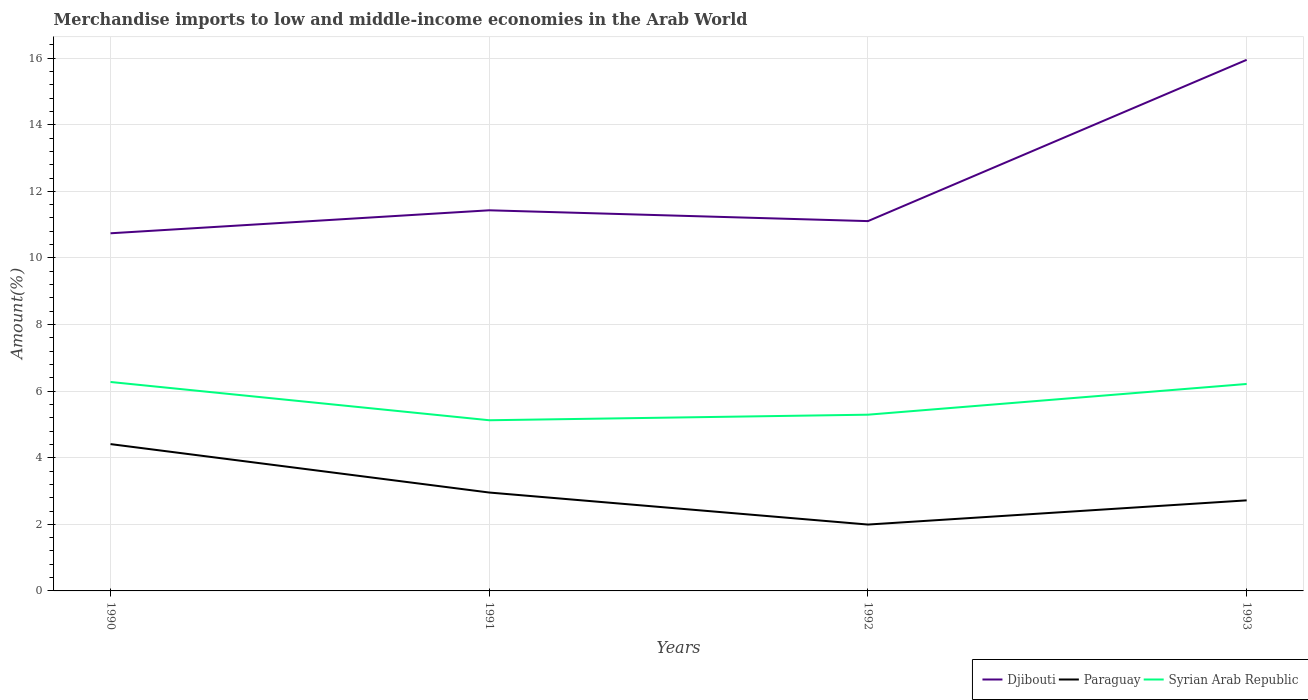Does the line corresponding to Syrian Arab Republic intersect with the line corresponding to Djibouti?
Ensure brevity in your answer.  No. Across all years, what is the maximum percentage of amount earned from merchandise imports in Djibouti?
Your answer should be compact. 10.74. What is the total percentage of amount earned from merchandise imports in Syrian Arab Republic in the graph?
Your answer should be very brief. 0.06. What is the difference between the highest and the second highest percentage of amount earned from merchandise imports in Paraguay?
Offer a terse response. 2.42. What is the difference between the highest and the lowest percentage of amount earned from merchandise imports in Djibouti?
Ensure brevity in your answer.  1. Is the percentage of amount earned from merchandise imports in Paraguay strictly greater than the percentage of amount earned from merchandise imports in Djibouti over the years?
Your answer should be very brief. Yes. How many lines are there?
Provide a short and direct response. 3. How many years are there in the graph?
Make the answer very short. 4. Where does the legend appear in the graph?
Your answer should be very brief. Bottom right. How many legend labels are there?
Offer a terse response. 3. How are the legend labels stacked?
Your response must be concise. Horizontal. What is the title of the graph?
Keep it short and to the point. Merchandise imports to low and middle-income economies in the Arab World. What is the label or title of the Y-axis?
Your response must be concise. Amount(%). What is the Amount(%) of Djibouti in 1990?
Your answer should be compact. 10.74. What is the Amount(%) in Paraguay in 1990?
Your response must be concise. 4.41. What is the Amount(%) of Syrian Arab Republic in 1990?
Your response must be concise. 6.27. What is the Amount(%) of Djibouti in 1991?
Your answer should be compact. 11.43. What is the Amount(%) in Paraguay in 1991?
Your answer should be very brief. 2.95. What is the Amount(%) in Syrian Arab Republic in 1991?
Offer a terse response. 5.13. What is the Amount(%) in Djibouti in 1992?
Your answer should be very brief. 11.11. What is the Amount(%) of Paraguay in 1992?
Offer a terse response. 1.99. What is the Amount(%) in Syrian Arab Republic in 1992?
Make the answer very short. 5.29. What is the Amount(%) of Djibouti in 1993?
Your answer should be very brief. 15.95. What is the Amount(%) of Paraguay in 1993?
Your response must be concise. 2.72. What is the Amount(%) in Syrian Arab Republic in 1993?
Make the answer very short. 6.22. Across all years, what is the maximum Amount(%) of Djibouti?
Provide a succinct answer. 15.95. Across all years, what is the maximum Amount(%) of Paraguay?
Make the answer very short. 4.41. Across all years, what is the maximum Amount(%) of Syrian Arab Republic?
Your answer should be very brief. 6.27. Across all years, what is the minimum Amount(%) of Djibouti?
Keep it short and to the point. 10.74. Across all years, what is the minimum Amount(%) in Paraguay?
Ensure brevity in your answer.  1.99. Across all years, what is the minimum Amount(%) in Syrian Arab Republic?
Provide a short and direct response. 5.13. What is the total Amount(%) in Djibouti in the graph?
Give a very brief answer. 49.23. What is the total Amount(%) of Paraguay in the graph?
Your answer should be very brief. 12.08. What is the total Amount(%) of Syrian Arab Republic in the graph?
Give a very brief answer. 22.91. What is the difference between the Amount(%) in Djibouti in 1990 and that in 1991?
Make the answer very short. -0.69. What is the difference between the Amount(%) in Paraguay in 1990 and that in 1991?
Keep it short and to the point. 1.45. What is the difference between the Amount(%) of Syrian Arab Republic in 1990 and that in 1991?
Provide a succinct answer. 1.15. What is the difference between the Amount(%) of Djibouti in 1990 and that in 1992?
Offer a very short reply. -0.37. What is the difference between the Amount(%) in Paraguay in 1990 and that in 1992?
Provide a short and direct response. 2.42. What is the difference between the Amount(%) in Syrian Arab Republic in 1990 and that in 1992?
Ensure brevity in your answer.  0.98. What is the difference between the Amount(%) in Djibouti in 1990 and that in 1993?
Ensure brevity in your answer.  -5.21. What is the difference between the Amount(%) of Paraguay in 1990 and that in 1993?
Make the answer very short. 1.69. What is the difference between the Amount(%) of Syrian Arab Republic in 1990 and that in 1993?
Keep it short and to the point. 0.06. What is the difference between the Amount(%) of Djibouti in 1991 and that in 1992?
Make the answer very short. 0.32. What is the difference between the Amount(%) of Paraguay in 1991 and that in 1992?
Offer a terse response. 0.96. What is the difference between the Amount(%) in Syrian Arab Republic in 1991 and that in 1992?
Ensure brevity in your answer.  -0.17. What is the difference between the Amount(%) of Djibouti in 1991 and that in 1993?
Offer a terse response. -4.52. What is the difference between the Amount(%) of Paraguay in 1991 and that in 1993?
Keep it short and to the point. 0.23. What is the difference between the Amount(%) in Syrian Arab Republic in 1991 and that in 1993?
Your answer should be very brief. -1.09. What is the difference between the Amount(%) in Djibouti in 1992 and that in 1993?
Ensure brevity in your answer.  -4.84. What is the difference between the Amount(%) of Paraguay in 1992 and that in 1993?
Make the answer very short. -0.73. What is the difference between the Amount(%) in Syrian Arab Republic in 1992 and that in 1993?
Make the answer very short. -0.92. What is the difference between the Amount(%) of Djibouti in 1990 and the Amount(%) of Paraguay in 1991?
Give a very brief answer. 7.79. What is the difference between the Amount(%) in Djibouti in 1990 and the Amount(%) in Syrian Arab Republic in 1991?
Your answer should be very brief. 5.61. What is the difference between the Amount(%) of Paraguay in 1990 and the Amount(%) of Syrian Arab Republic in 1991?
Your response must be concise. -0.72. What is the difference between the Amount(%) of Djibouti in 1990 and the Amount(%) of Paraguay in 1992?
Your answer should be compact. 8.75. What is the difference between the Amount(%) in Djibouti in 1990 and the Amount(%) in Syrian Arab Republic in 1992?
Provide a short and direct response. 5.45. What is the difference between the Amount(%) in Paraguay in 1990 and the Amount(%) in Syrian Arab Republic in 1992?
Provide a succinct answer. -0.88. What is the difference between the Amount(%) in Djibouti in 1990 and the Amount(%) in Paraguay in 1993?
Provide a short and direct response. 8.02. What is the difference between the Amount(%) in Djibouti in 1990 and the Amount(%) in Syrian Arab Republic in 1993?
Ensure brevity in your answer.  4.53. What is the difference between the Amount(%) of Paraguay in 1990 and the Amount(%) of Syrian Arab Republic in 1993?
Make the answer very short. -1.81. What is the difference between the Amount(%) in Djibouti in 1991 and the Amount(%) in Paraguay in 1992?
Make the answer very short. 9.44. What is the difference between the Amount(%) of Djibouti in 1991 and the Amount(%) of Syrian Arab Republic in 1992?
Offer a very short reply. 6.14. What is the difference between the Amount(%) in Paraguay in 1991 and the Amount(%) in Syrian Arab Republic in 1992?
Ensure brevity in your answer.  -2.34. What is the difference between the Amount(%) in Djibouti in 1991 and the Amount(%) in Paraguay in 1993?
Make the answer very short. 8.71. What is the difference between the Amount(%) in Djibouti in 1991 and the Amount(%) in Syrian Arab Republic in 1993?
Offer a terse response. 5.22. What is the difference between the Amount(%) of Paraguay in 1991 and the Amount(%) of Syrian Arab Republic in 1993?
Ensure brevity in your answer.  -3.26. What is the difference between the Amount(%) in Djibouti in 1992 and the Amount(%) in Paraguay in 1993?
Give a very brief answer. 8.39. What is the difference between the Amount(%) of Djibouti in 1992 and the Amount(%) of Syrian Arab Republic in 1993?
Your answer should be compact. 4.89. What is the difference between the Amount(%) of Paraguay in 1992 and the Amount(%) of Syrian Arab Republic in 1993?
Ensure brevity in your answer.  -4.22. What is the average Amount(%) in Djibouti per year?
Your response must be concise. 12.31. What is the average Amount(%) of Paraguay per year?
Your response must be concise. 3.02. What is the average Amount(%) in Syrian Arab Republic per year?
Provide a succinct answer. 5.73. In the year 1990, what is the difference between the Amount(%) in Djibouti and Amount(%) in Paraguay?
Offer a terse response. 6.33. In the year 1990, what is the difference between the Amount(%) of Djibouti and Amount(%) of Syrian Arab Republic?
Offer a terse response. 4.47. In the year 1990, what is the difference between the Amount(%) of Paraguay and Amount(%) of Syrian Arab Republic?
Offer a very short reply. -1.87. In the year 1991, what is the difference between the Amount(%) in Djibouti and Amount(%) in Paraguay?
Offer a terse response. 8.48. In the year 1991, what is the difference between the Amount(%) of Djibouti and Amount(%) of Syrian Arab Republic?
Your response must be concise. 6.31. In the year 1991, what is the difference between the Amount(%) in Paraguay and Amount(%) in Syrian Arab Republic?
Offer a very short reply. -2.17. In the year 1992, what is the difference between the Amount(%) in Djibouti and Amount(%) in Paraguay?
Your response must be concise. 9.11. In the year 1992, what is the difference between the Amount(%) in Djibouti and Amount(%) in Syrian Arab Republic?
Provide a short and direct response. 5.81. In the year 1992, what is the difference between the Amount(%) of Paraguay and Amount(%) of Syrian Arab Republic?
Your answer should be compact. -3.3. In the year 1993, what is the difference between the Amount(%) in Djibouti and Amount(%) in Paraguay?
Offer a terse response. 13.23. In the year 1993, what is the difference between the Amount(%) in Djibouti and Amount(%) in Syrian Arab Republic?
Ensure brevity in your answer.  9.73. In the year 1993, what is the difference between the Amount(%) of Paraguay and Amount(%) of Syrian Arab Republic?
Ensure brevity in your answer.  -3.5. What is the ratio of the Amount(%) in Djibouti in 1990 to that in 1991?
Provide a succinct answer. 0.94. What is the ratio of the Amount(%) in Paraguay in 1990 to that in 1991?
Your answer should be very brief. 1.49. What is the ratio of the Amount(%) of Syrian Arab Republic in 1990 to that in 1991?
Your answer should be compact. 1.22. What is the ratio of the Amount(%) in Djibouti in 1990 to that in 1992?
Offer a terse response. 0.97. What is the ratio of the Amount(%) of Paraguay in 1990 to that in 1992?
Give a very brief answer. 2.21. What is the ratio of the Amount(%) of Syrian Arab Republic in 1990 to that in 1992?
Offer a terse response. 1.19. What is the ratio of the Amount(%) in Djibouti in 1990 to that in 1993?
Your answer should be very brief. 0.67. What is the ratio of the Amount(%) of Paraguay in 1990 to that in 1993?
Your response must be concise. 1.62. What is the ratio of the Amount(%) of Syrian Arab Republic in 1990 to that in 1993?
Offer a very short reply. 1.01. What is the ratio of the Amount(%) of Djibouti in 1991 to that in 1992?
Offer a very short reply. 1.03. What is the ratio of the Amount(%) in Paraguay in 1991 to that in 1992?
Provide a short and direct response. 1.48. What is the ratio of the Amount(%) of Syrian Arab Republic in 1991 to that in 1992?
Your answer should be very brief. 0.97. What is the ratio of the Amount(%) in Djibouti in 1991 to that in 1993?
Your answer should be very brief. 0.72. What is the ratio of the Amount(%) of Paraguay in 1991 to that in 1993?
Offer a very short reply. 1.09. What is the ratio of the Amount(%) of Syrian Arab Republic in 1991 to that in 1993?
Provide a short and direct response. 0.82. What is the ratio of the Amount(%) of Djibouti in 1992 to that in 1993?
Your response must be concise. 0.7. What is the ratio of the Amount(%) in Paraguay in 1992 to that in 1993?
Provide a succinct answer. 0.73. What is the ratio of the Amount(%) in Syrian Arab Republic in 1992 to that in 1993?
Your response must be concise. 0.85. What is the difference between the highest and the second highest Amount(%) of Djibouti?
Your answer should be very brief. 4.52. What is the difference between the highest and the second highest Amount(%) in Paraguay?
Provide a short and direct response. 1.45. What is the difference between the highest and the second highest Amount(%) of Syrian Arab Republic?
Offer a very short reply. 0.06. What is the difference between the highest and the lowest Amount(%) of Djibouti?
Make the answer very short. 5.21. What is the difference between the highest and the lowest Amount(%) of Paraguay?
Give a very brief answer. 2.42. What is the difference between the highest and the lowest Amount(%) in Syrian Arab Republic?
Ensure brevity in your answer.  1.15. 